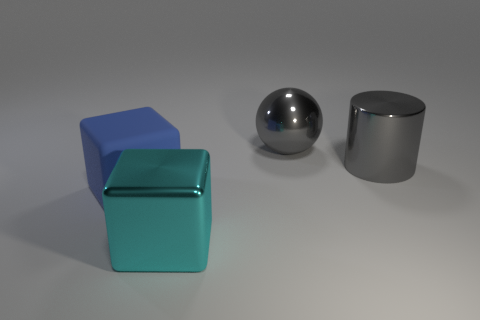Considering the surface texture, which object would have the smoothest feel? Judging by the visual reflections and appearance, the spherical object would likely have the smoothest feel due to its reflective, unblemished surface, suggesting a highly polished texture. 